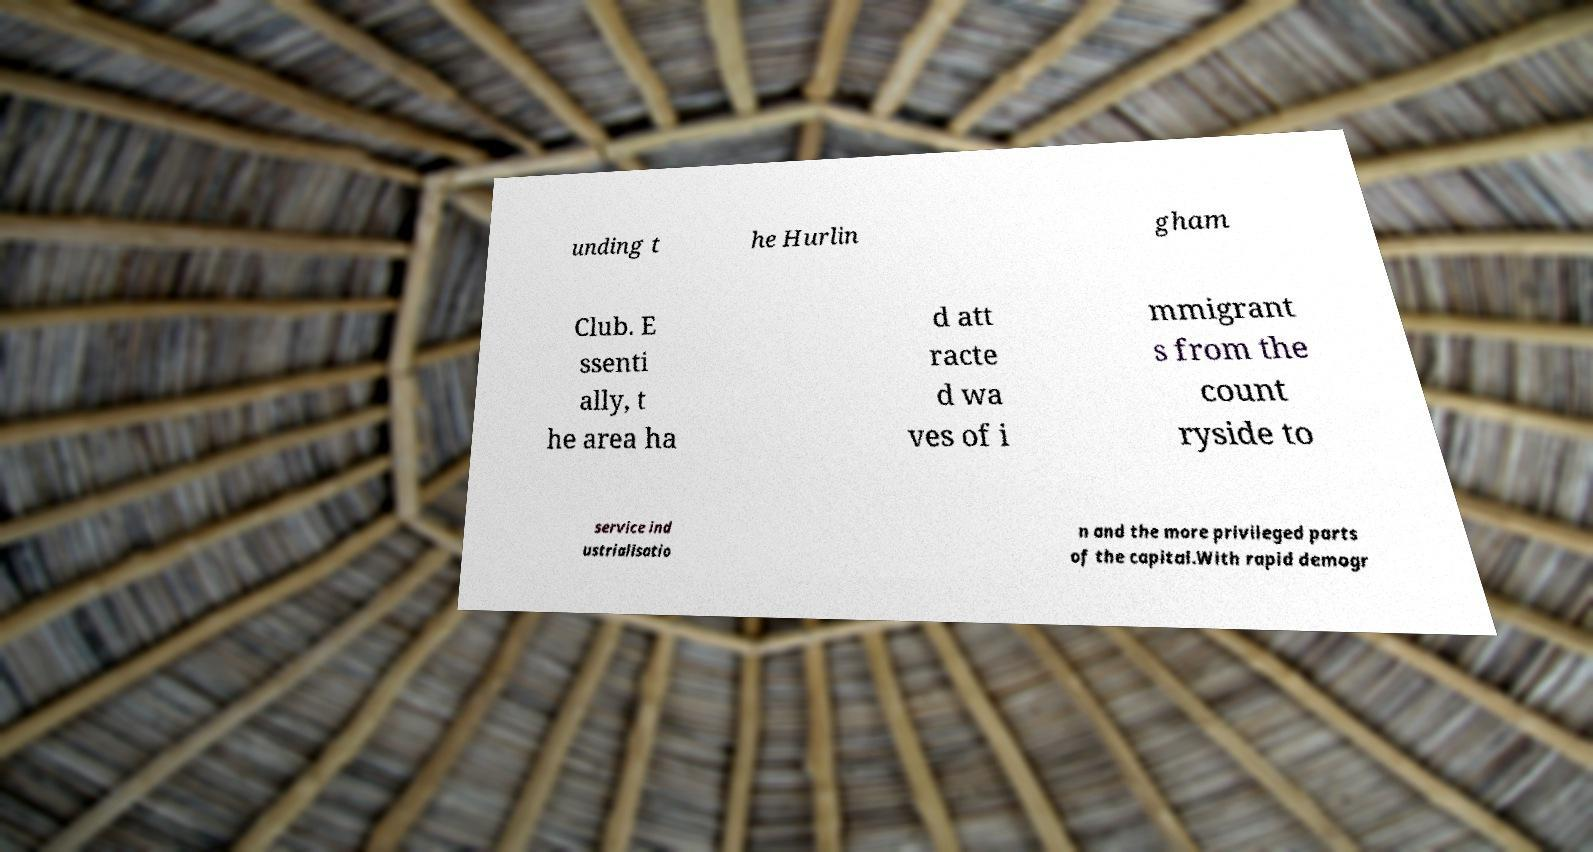What messages or text are displayed in this image? I need them in a readable, typed format. unding t he Hurlin gham Club. E ssenti ally, t he area ha d att racte d wa ves of i mmigrant s from the count ryside to service ind ustrialisatio n and the more privileged parts of the capital.With rapid demogr 